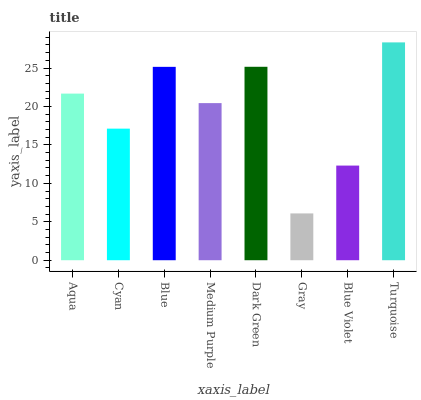Is Cyan the minimum?
Answer yes or no. No. Is Cyan the maximum?
Answer yes or no. No. Is Aqua greater than Cyan?
Answer yes or no. Yes. Is Cyan less than Aqua?
Answer yes or no. Yes. Is Cyan greater than Aqua?
Answer yes or no. No. Is Aqua less than Cyan?
Answer yes or no. No. Is Aqua the high median?
Answer yes or no. Yes. Is Medium Purple the low median?
Answer yes or no. Yes. Is Gray the high median?
Answer yes or no. No. Is Gray the low median?
Answer yes or no. No. 